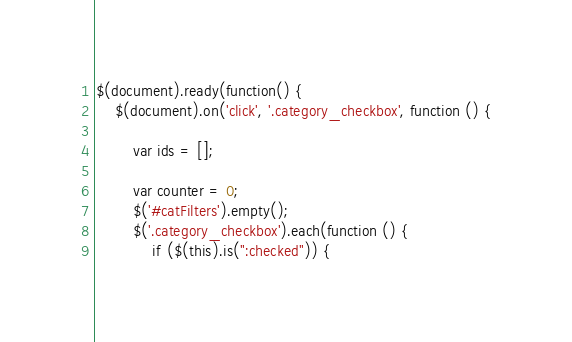Convert code to text. <code><loc_0><loc_0><loc_500><loc_500><_JavaScript_>$(document).ready(function() {
    $(document).on('click', '.category_checkbox', function () {

        var ids = [];

        var counter = 0;
        $('#catFilters').empty();
        $('.category_checkbox').each(function () {
            if ($(this).is(":checked")) {</code> 